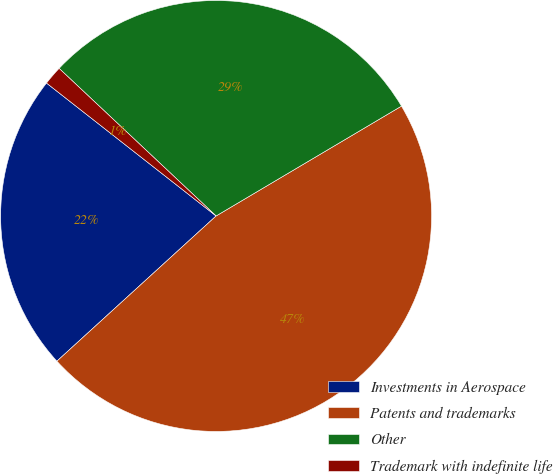Convert chart to OTSL. <chart><loc_0><loc_0><loc_500><loc_500><pie_chart><fcel>Investments in Aerospace<fcel>Patents and trademarks<fcel>Other<fcel>Trademark with indefinite life<nl><fcel>22.35%<fcel>46.75%<fcel>29.48%<fcel>1.43%<nl></chart> 